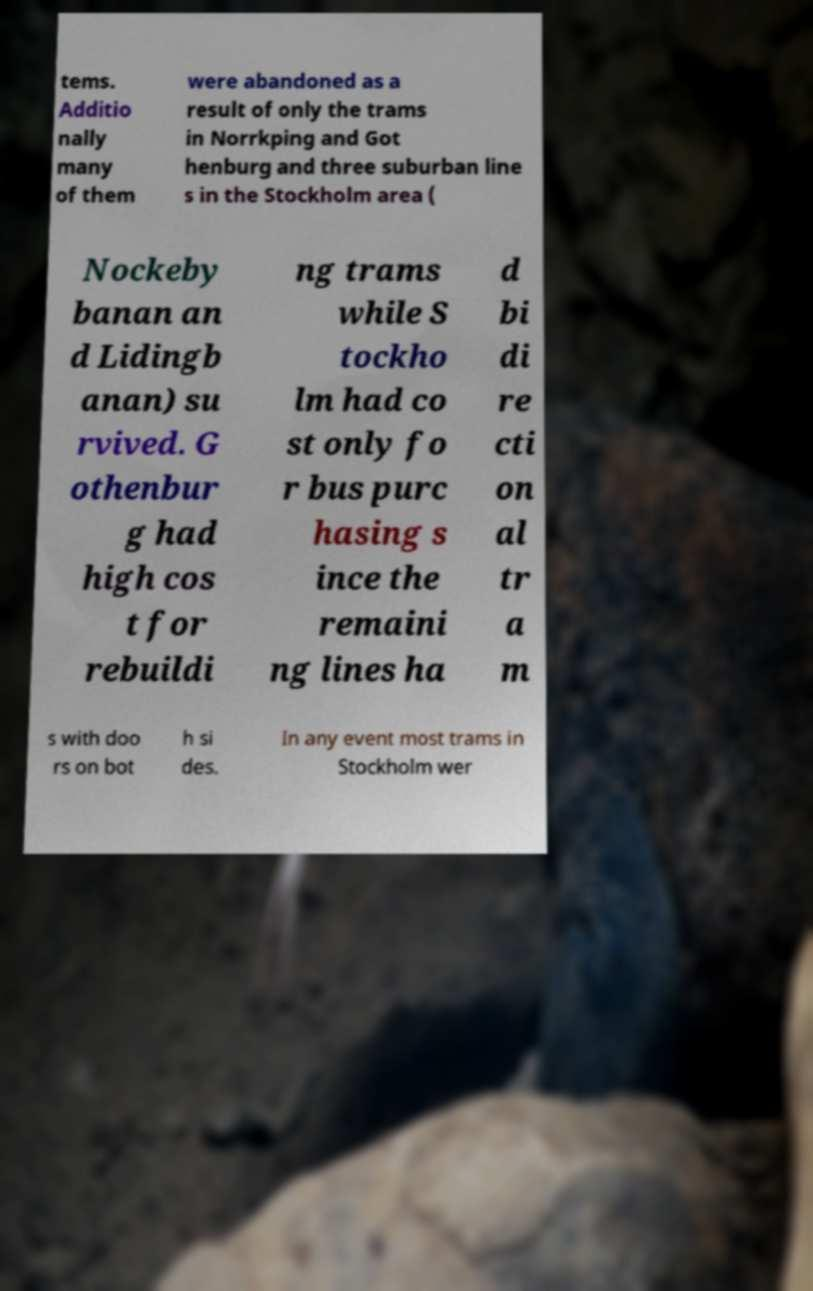Could you assist in decoding the text presented in this image and type it out clearly? tems. Additio nally many of them were abandoned as a result of only the trams in Norrkping and Got henburg and three suburban line s in the Stockholm area ( Nockeby banan an d Lidingb anan) su rvived. G othenbur g had high cos t for rebuildi ng trams while S tockho lm had co st only fo r bus purc hasing s ince the remaini ng lines ha d bi di re cti on al tr a m s with doo rs on bot h si des. In any event most trams in Stockholm wer 